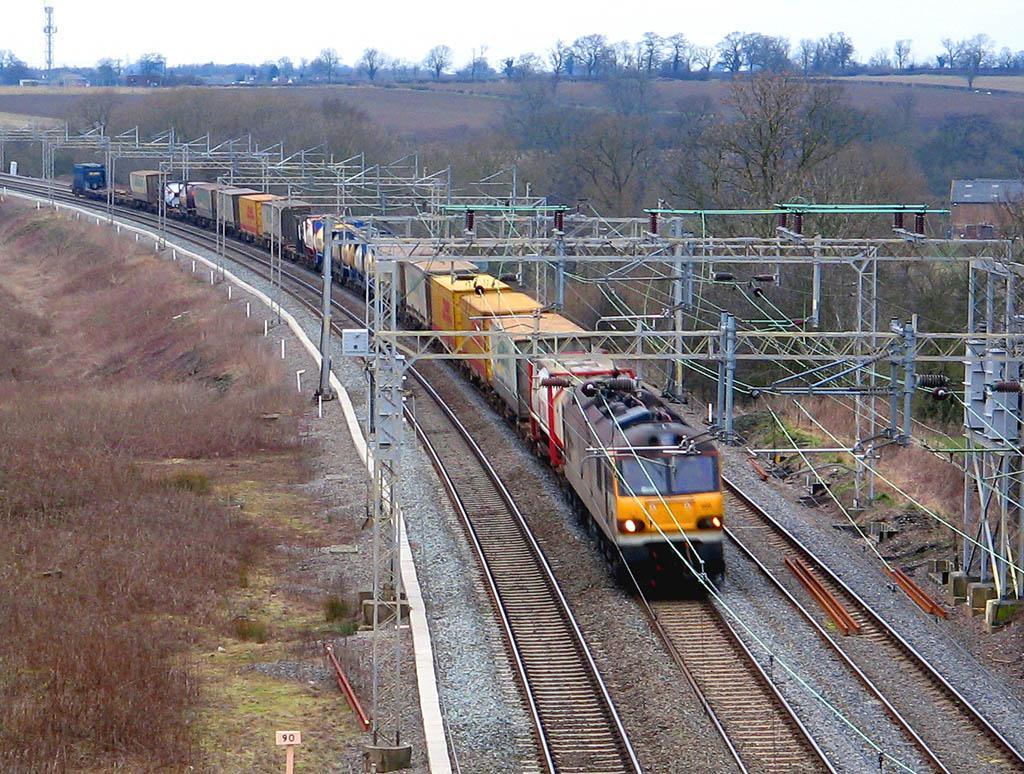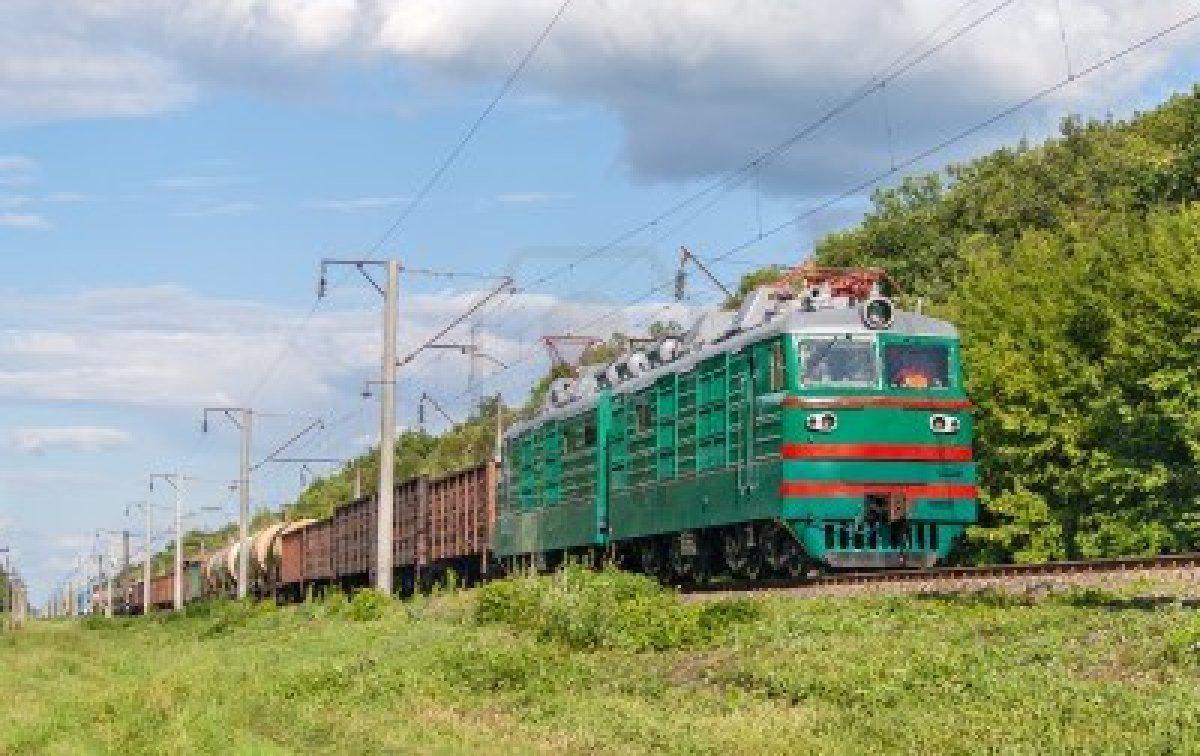The first image is the image on the left, the second image is the image on the right. Examine the images to the left and right. Is the description "At least one train has a visibly sloped front with a band of solid color around the windshield." accurate? Answer yes or no. No. The first image is the image on the left, the second image is the image on the right. Examine the images to the left and right. Is the description "The train in the image to the right features a fair amount of green paint." accurate? Answer yes or no. Yes. 